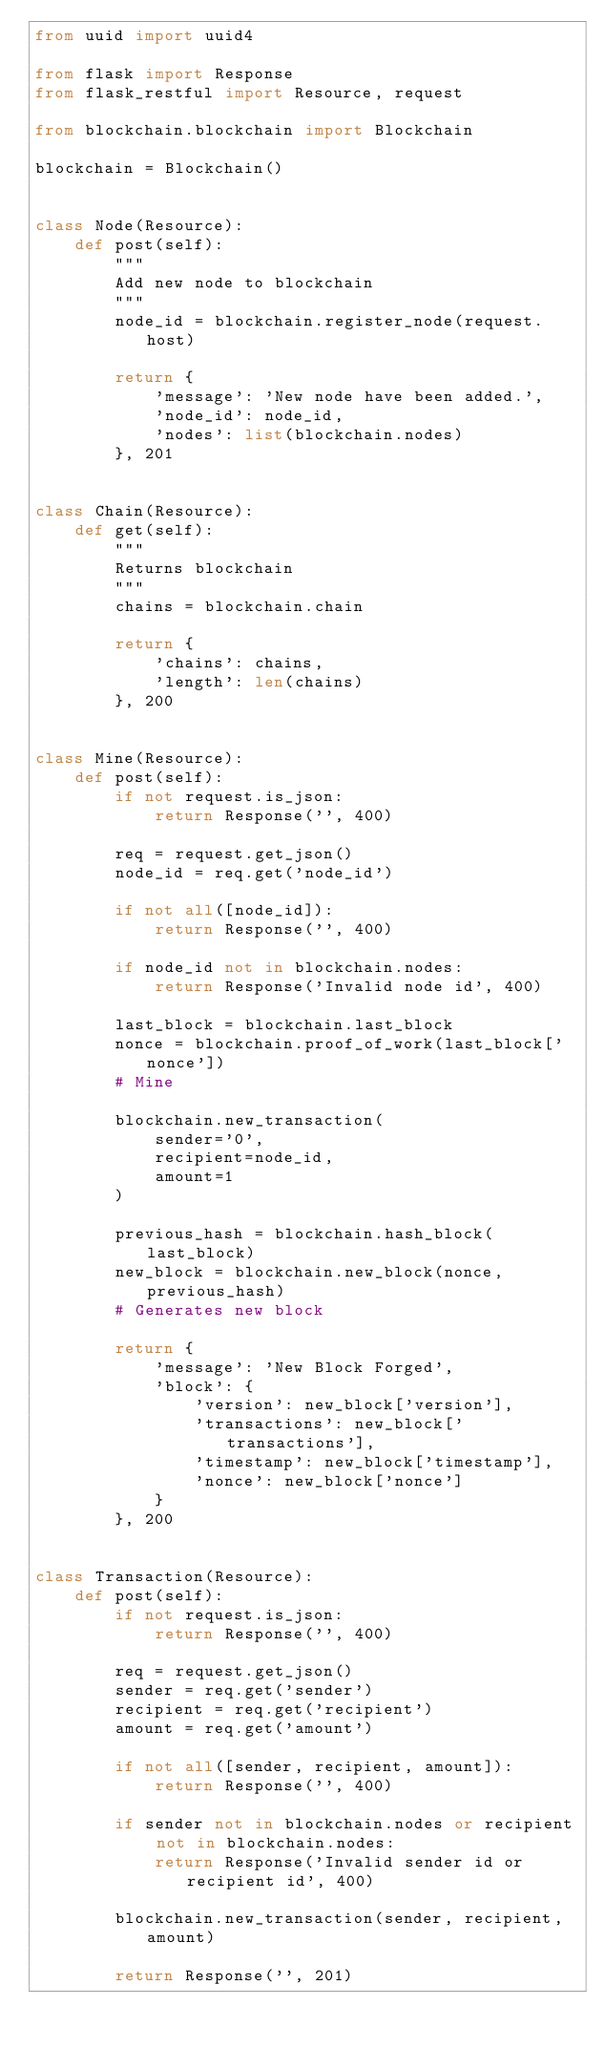<code> <loc_0><loc_0><loc_500><loc_500><_Python_>from uuid import uuid4

from flask import Response
from flask_restful import Resource, request

from blockchain.blockchain import Blockchain

blockchain = Blockchain()


class Node(Resource):
    def post(self):
        """
        Add new node to blockchain
        """
        node_id = blockchain.register_node(request.host)

        return {
            'message': 'New node have been added.',
            'node_id': node_id,
            'nodes': list(blockchain.nodes)
        }, 201


class Chain(Resource):
    def get(self):
        """
        Returns blockchain
        """
        chains = blockchain.chain

        return {
            'chains': chains,
            'length': len(chains)
        }, 200


class Mine(Resource):
    def post(self):
        if not request.is_json:
            return Response('', 400)

        req = request.get_json()
        node_id = req.get('node_id')

        if not all([node_id]):
            return Response('', 400)

        if node_id not in blockchain.nodes:
            return Response('Invalid node id', 400)

        last_block = blockchain.last_block
        nonce = blockchain.proof_of_work(last_block['nonce'])
        # Mine

        blockchain.new_transaction(
            sender='0',
            recipient=node_id,
            amount=1
        )

        previous_hash = blockchain.hash_block(last_block)
        new_block = blockchain.new_block(nonce, previous_hash)
        # Generates new block

        return {
            'message': 'New Block Forged',
            'block': {
                'version': new_block['version'],
                'transactions': new_block['transactions'],
                'timestamp': new_block['timestamp'],
                'nonce': new_block['nonce']
            }
        }, 200


class Transaction(Resource):
    def post(self):
        if not request.is_json:
            return Response('', 400)

        req = request.get_json()
        sender = req.get('sender')
        recipient = req.get('recipient')
        amount = req.get('amount')

        if not all([sender, recipient, amount]):
            return Response('', 400)

        if sender not in blockchain.nodes or recipient not in blockchain.nodes:
            return Response('Invalid sender id or recipient id', 400)

        blockchain.new_transaction(sender, recipient, amount)

        return Response('', 201)</code> 